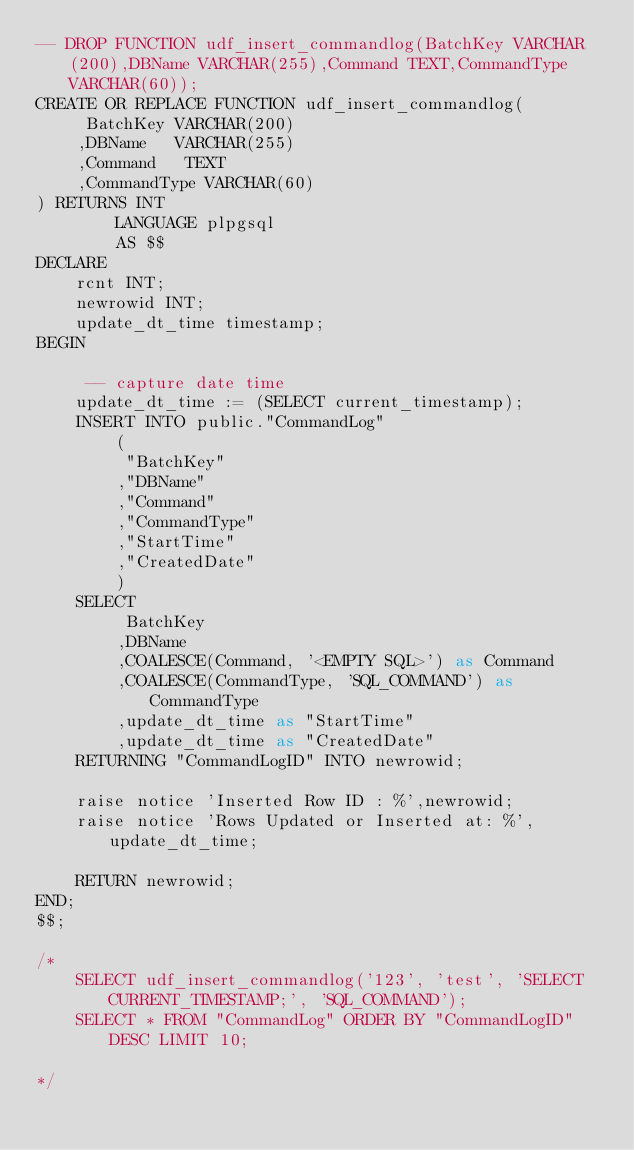<code> <loc_0><loc_0><loc_500><loc_500><_SQL_>-- DROP FUNCTION udf_insert_commandlog(BatchKey VARCHAR(200),DBName VARCHAR(255),Command TEXT,CommandType VARCHAR(60));
CREATE OR REPLACE FUNCTION udf_insert_commandlog(
     BatchKey VARCHAR(200)
    ,DBName   VARCHAR(255)
    ,Command   TEXT
    ,CommandType VARCHAR(60)
) RETURNS INT 
        LANGUAGE plpgsql
        AS $$
DECLARE
    rcnt INT;
    newrowid INT;
    update_dt_time timestamp;
BEGIN
   
     -- capture date time
    update_dt_time := (SELECT current_timestamp);
    INSERT INTO public."CommandLog"
        (
         "BatchKey"
        ,"DBName"
        ,"Command"
        ,"CommandType"
        ,"StartTime"
        ,"CreatedDate"
        )
    SELECT   
         BatchKey
        ,DBName
        ,COALESCE(Command, '<EMPTY SQL>') as Command
        ,COALESCE(CommandType, 'SQL_COMMAND') as CommandType
        ,update_dt_time as "StartTime"
        ,update_dt_time as "CreatedDate"
    RETURNING "CommandLogID" INTO newrowid;

    raise notice 'Inserted Row ID : %',newrowid;
    raise notice 'Rows Updated or Inserted at: %', update_dt_time;

    RETURN newrowid;
END;
$$;

/*
    SELECT udf_insert_commandlog('123', 'test', 'SELECT CURRENT_TIMESTAMP;', 'SQL_COMMAND');
    SELECT * FROM "CommandLog" ORDER BY "CommandLogID" DESC LIMIT 10;

*/</code> 